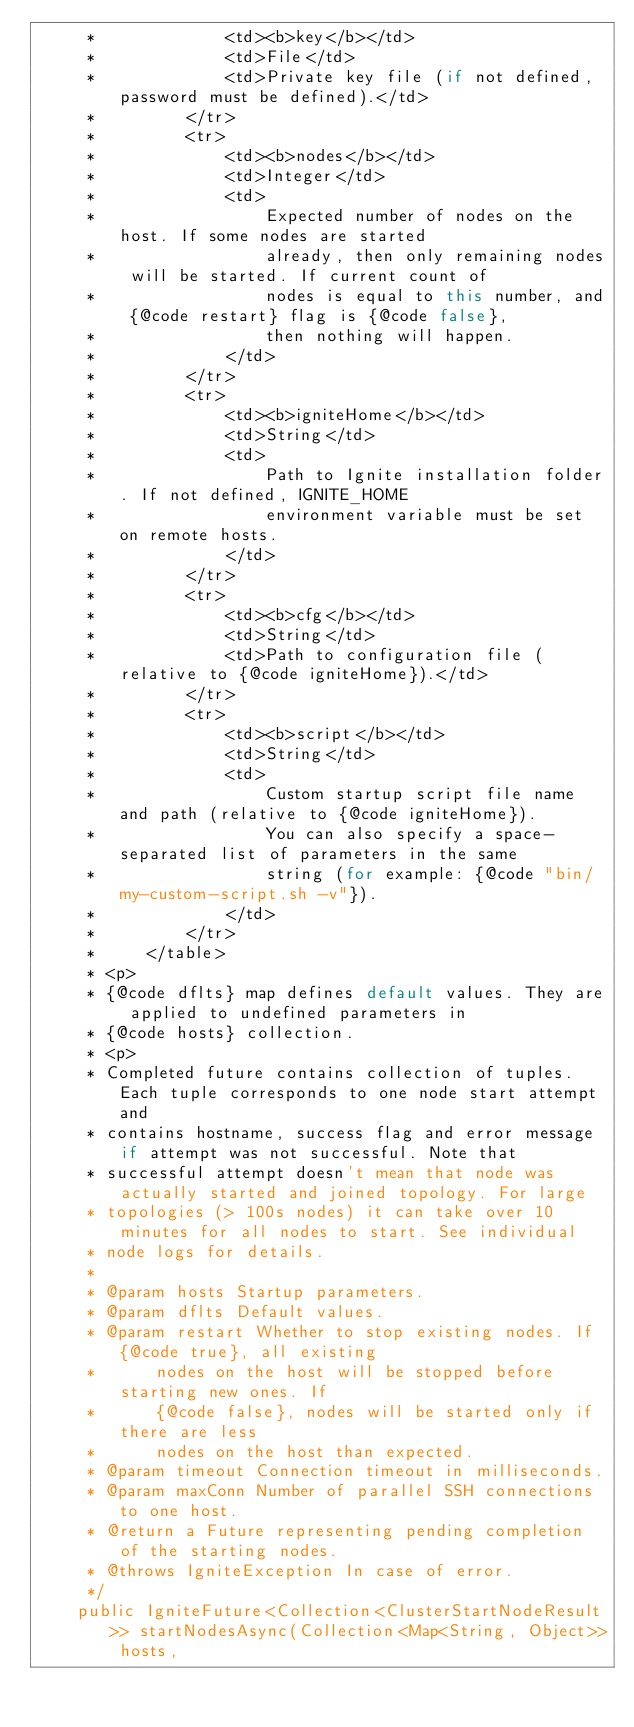<code> <loc_0><loc_0><loc_500><loc_500><_Java_>     *             <td><b>key</b></td>
     *             <td>File</td>
     *             <td>Private key file (if not defined, password must be defined).</td>
     *         </tr>
     *         <tr>
     *             <td><b>nodes</b></td>
     *             <td>Integer</td>
     *             <td>
     *                 Expected number of nodes on the host. If some nodes are started
     *                 already, then only remaining nodes will be started. If current count of
     *                 nodes is equal to this number, and {@code restart} flag is {@code false},
     *                 then nothing will happen.
     *             </td>
     *         </tr>
     *         <tr>
     *             <td><b>igniteHome</b></td>
     *             <td>String</td>
     *             <td>
     *                 Path to Ignite installation folder. If not defined, IGNITE_HOME
     *                 environment variable must be set on remote hosts.
     *             </td>
     *         </tr>
     *         <tr>
     *             <td><b>cfg</b></td>
     *             <td>String</td>
     *             <td>Path to configuration file (relative to {@code igniteHome}).</td>
     *         </tr>
     *         <tr>
     *             <td><b>script</b></td>
     *             <td>String</td>
     *             <td>
     *                 Custom startup script file name and path (relative to {@code igniteHome}).
     *                 You can also specify a space-separated list of parameters in the same
     *                 string (for example: {@code "bin/my-custom-script.sh -v"}).
     *             </td>
     *         </tr>
     *     </table>
     * <p>
     * {@code dflts} map defines default values. They are applied to undefined parameters in
     * {@code hosts} collection.
     * <p>
     * Completed future contains collection of tuples. Each tuple corresponds to one node start attempt and
     * contains hostname, success flag and error message if attempt was not successful. Note that
     * successful attempt doesn't mean that node was actually started and joined topology. For large
     * topologies (> 100s nodes) it can take over 10 minutes for all nodes to start. See individual
     * node logs for details.
     *
     * @param hosts Startup parameters.
     * @param dflts Default values.
     * @param restart Whether to stop existing nodes. If {@code true}, all existing
     *      nodes on the host will be stopped before starting new ones. If
     *      {@code false}, nodes will be started only if there are less
     *      nodes on the host than expected.
     * @param timeout Connection timeout in milliseconds.
     * @param maxConn Number of parallel SSH connections to one host.
     * @return a Future representing pending completion of the starting nodes.
     * @throws IgniteException In case of error.
     */
    public IgniteFuture<Collection<ClusterStartNodeResult>> startNodesAsync(Collection<Map<String, Object>> hosts,</code> 